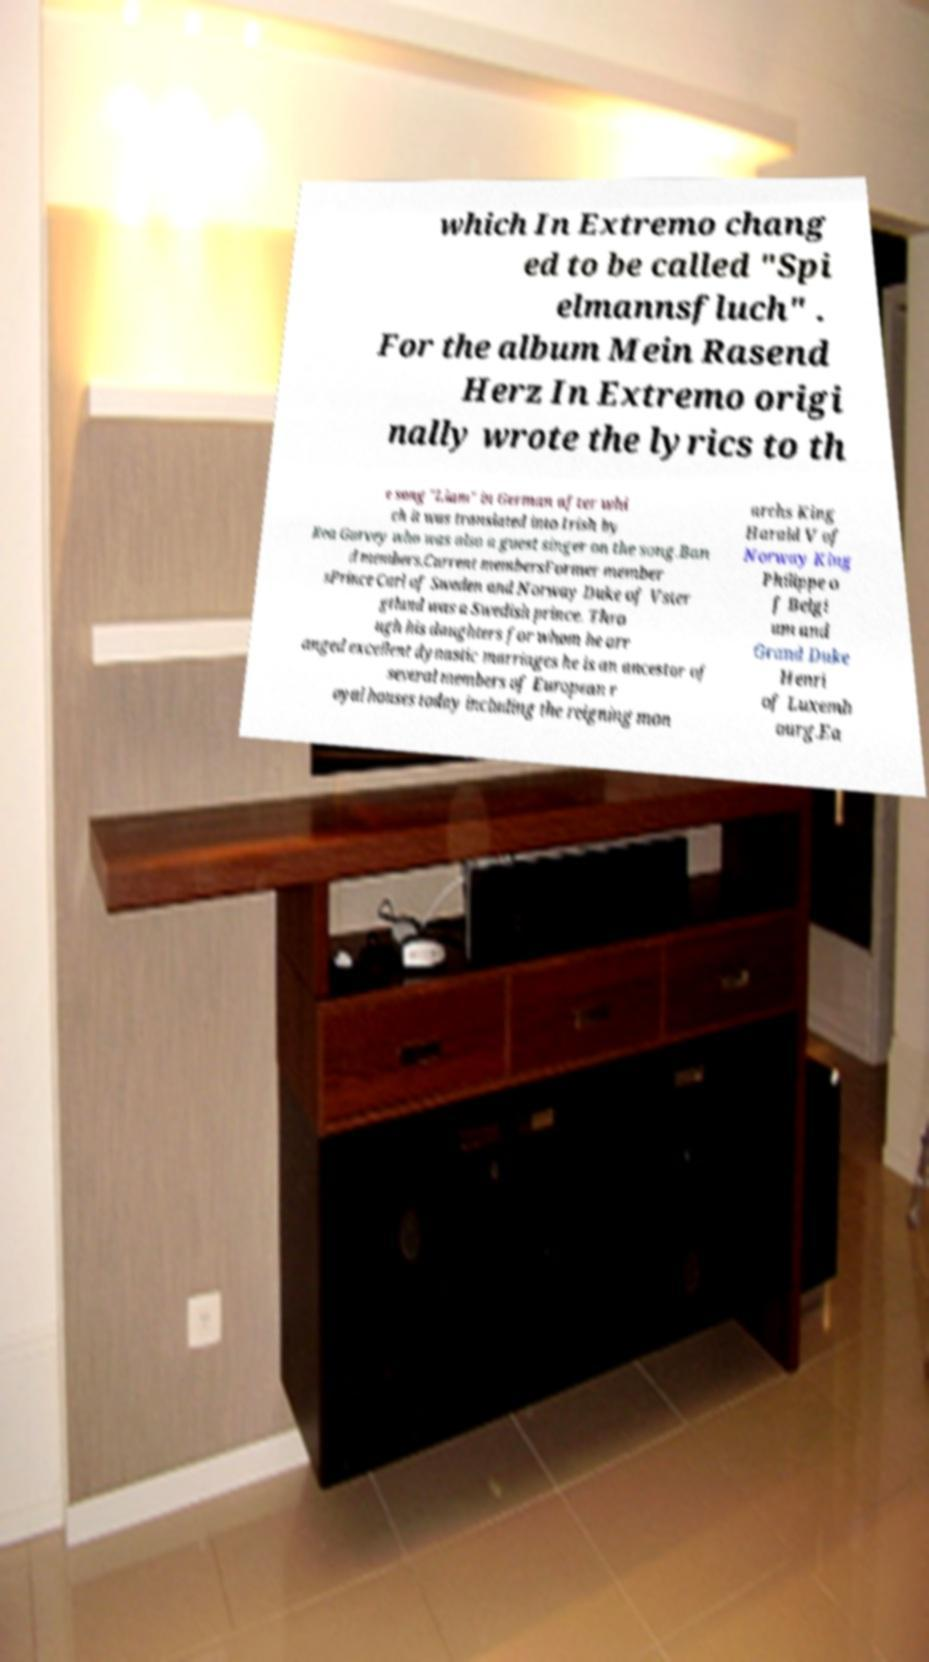Can you read and provide the text displayed in the image?This photo seems to have some interesting text. Can you extract and type it out for me? which In Extremo chang ed to be called "Spi elmannsfluch" . For the album Mein Rasend Herz In Extremo origi nally wrote the lyrics to th e song "Liam" in German after whi ch it was translated into Irish by Rea Garvey who was also a guest singer on the song.Ban d members.Current membersFormer member sPrince Carl of Sweden and Norway Duke of Vster gtland was a Swedish prince. Thro ugh his daughters for whom he arr anged excellent dynastic marriages he is an ancestor of several members of European r oyal houses today including the reigning mon archs King Harald V of Norway King Philippe o f Belgi um and Grand Duke Henri of Luxemb ourg.Ea 